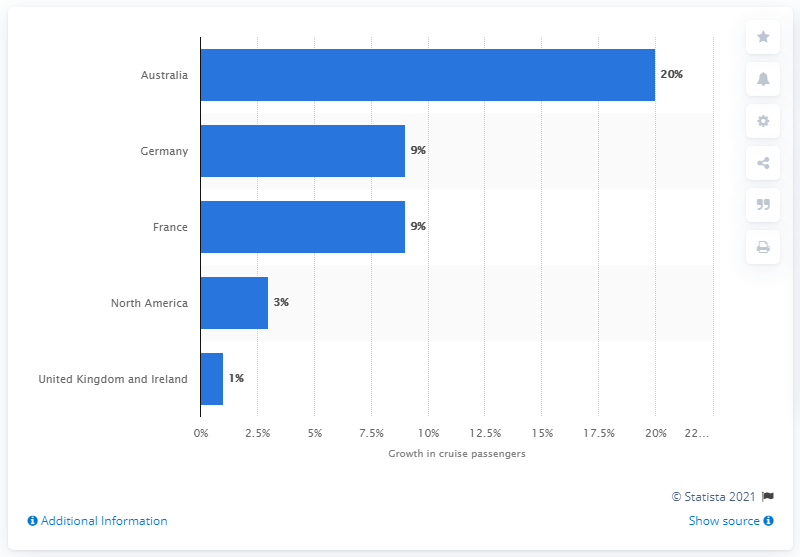What percentage of passenger numbers did Australia have in 2013?
 20 